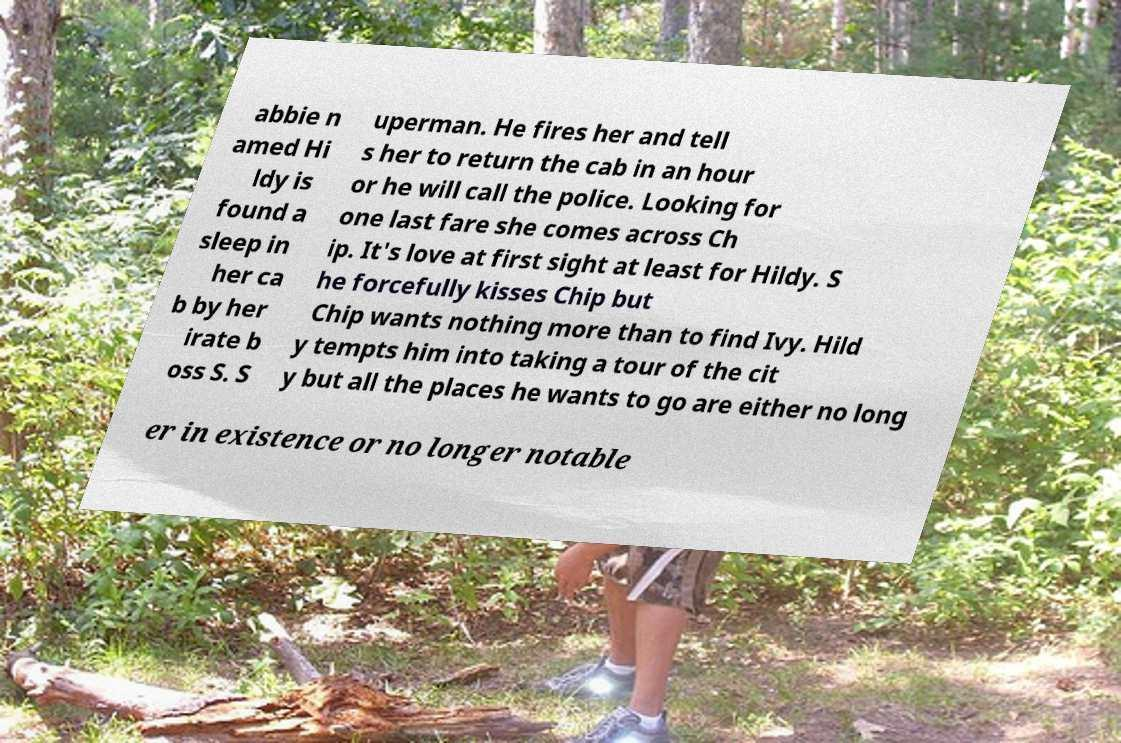I need the written content from this picture converted into text. Can you do that? abbie n amed Hi ldy is found a sleep in her ca b by her irate b oss S. S uperman. He fires her and tell s her to return the cab in an hour or he will call the police. Looking for one last fare she comes across Ch ip. It's love at first sight at least for Hildy. S he forcefully kisses Chip but Chip wants nothing more than to find Ivy. Hild y tempts him into taking a tour of the cit y but all the places he wants to go are either no long er in existence or no longer notable 